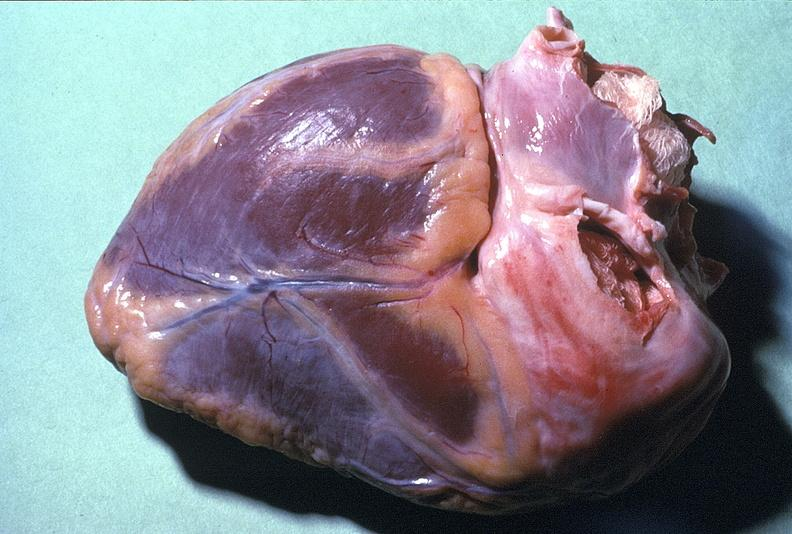where is this?
Answer the question using a single word or phrase. Heart 